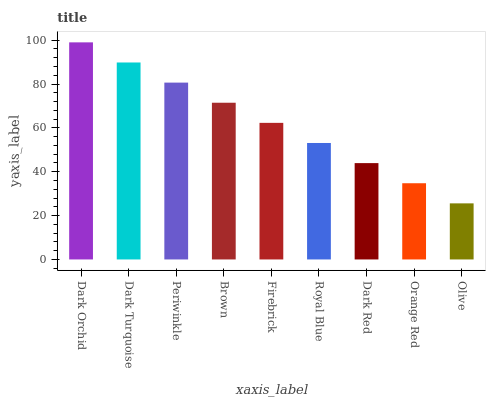Is Olive the minimum?
Answer yes or no. Yes. Is Dark Orchid the maximum?
Answer yes or no. Yes. Is Dark Turquoise the minimum?
Answer yes or no. No. Is Dark Turquoise the maximum?
Answer yes or no. No. Is Dark Orchid greater than Dark Turquoise?
Answer yes or no. Yes. Is Dark Turquoise less than Dark Orchid?
Answer yes or no. Yes. Is Dark Turquoise greater than Dark Orchid?
Answer yes or no. No. Is Dark Orchid less than Dark Turquoise?
Answer yes or no. No. Is Firebrick the high median?
Answer yes or no. Yes. Is Firebrick the low median?
Answer yes or no. Yes. Is Dark Orchid the high median?
Answer yes or no. No. Is Periwinkle the low median?
Answer yes or no. No. 